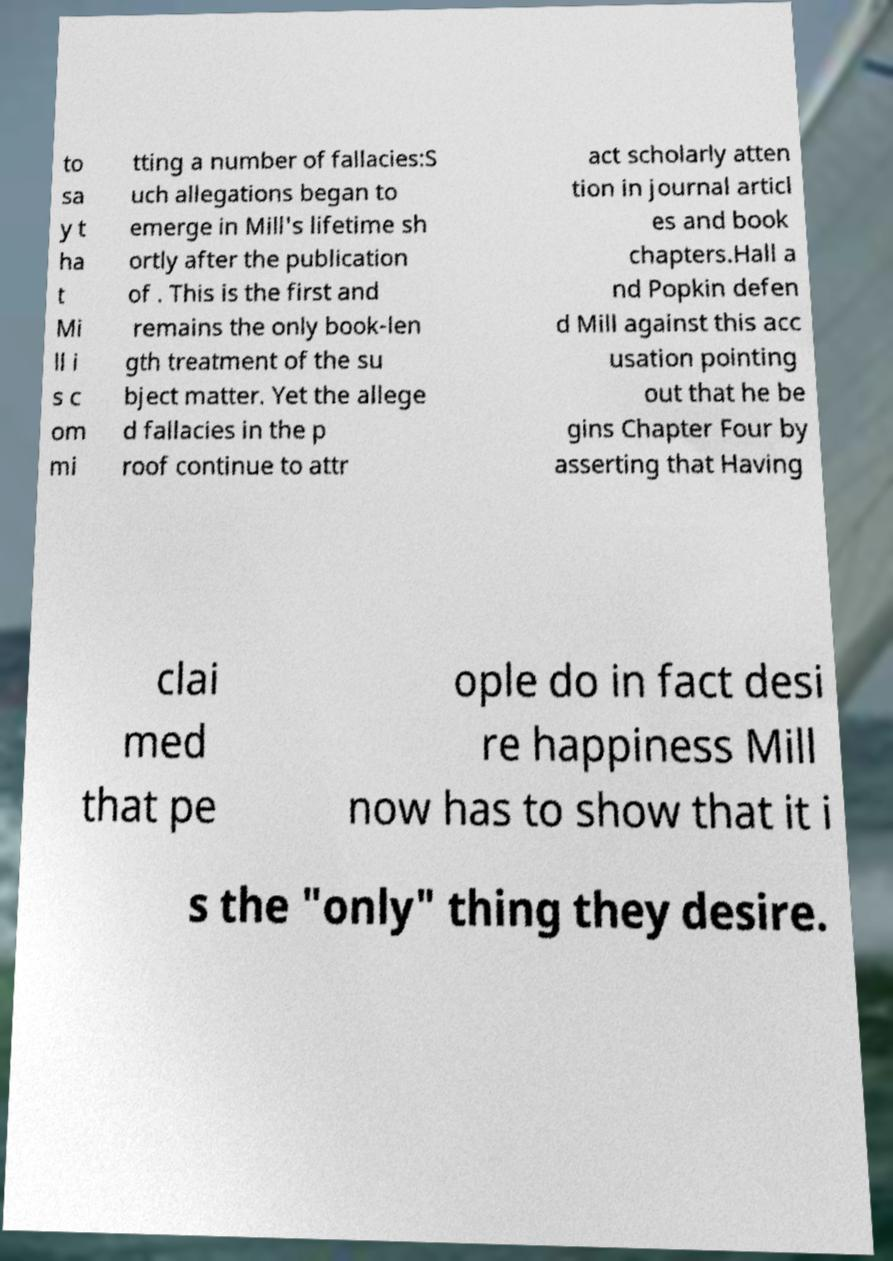For documentation purposes, I need the text within this image transcribed. Could you provide that? to sa y t ha t Mi ll i s c om mi tting a number of fallacies:S uch allegations began to emerge in Mill's lifetime sh ortly after the publication of . This is the first and remains the only book-len gth treatment of the su bject matter. Yet the allege d fallacies in the p roof continue to attr act scholarly atten tion in journal articl es and book chapters.Hall a nd Popkin defen d Mill against this acc usation pointing out that he be gins Chapter Four by asserting that Having clai med that pe ople do in fact desi re happiness Mill now has to show that it i s the "only" thing they desire. 